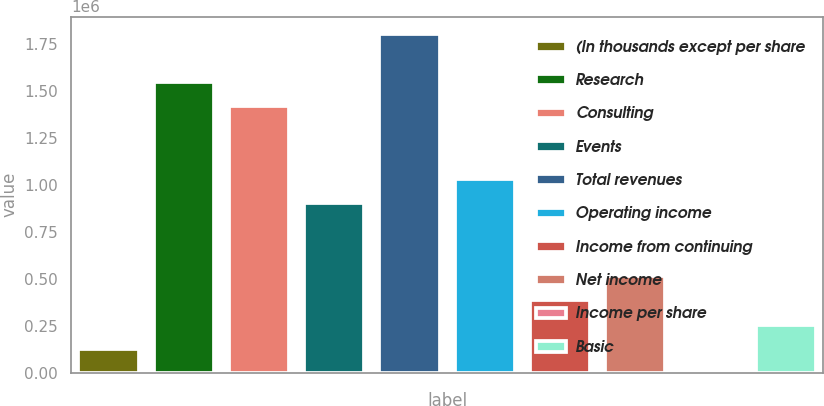<chart> <loc_0><loc_0><loc_500><loc_500><bar_chart><fcel>(In thousands except per share<fcel>Research<fcel>Consulting<fcel>Events<fcel>Total revenues<fcel>Operating income<fcel>Income from continuing<fcel>Net income<fcel>Income per share<fcel>Basic<nl><fcel>128846<fcel>1.54614e+06<fcel>1.4173e+06<fcel>901918<fcel>1.80384e+06<fcel>1.03076e+06<fcel>386537<fcel>515382<fcel>1.01<fcel>257692<nl></chart> 